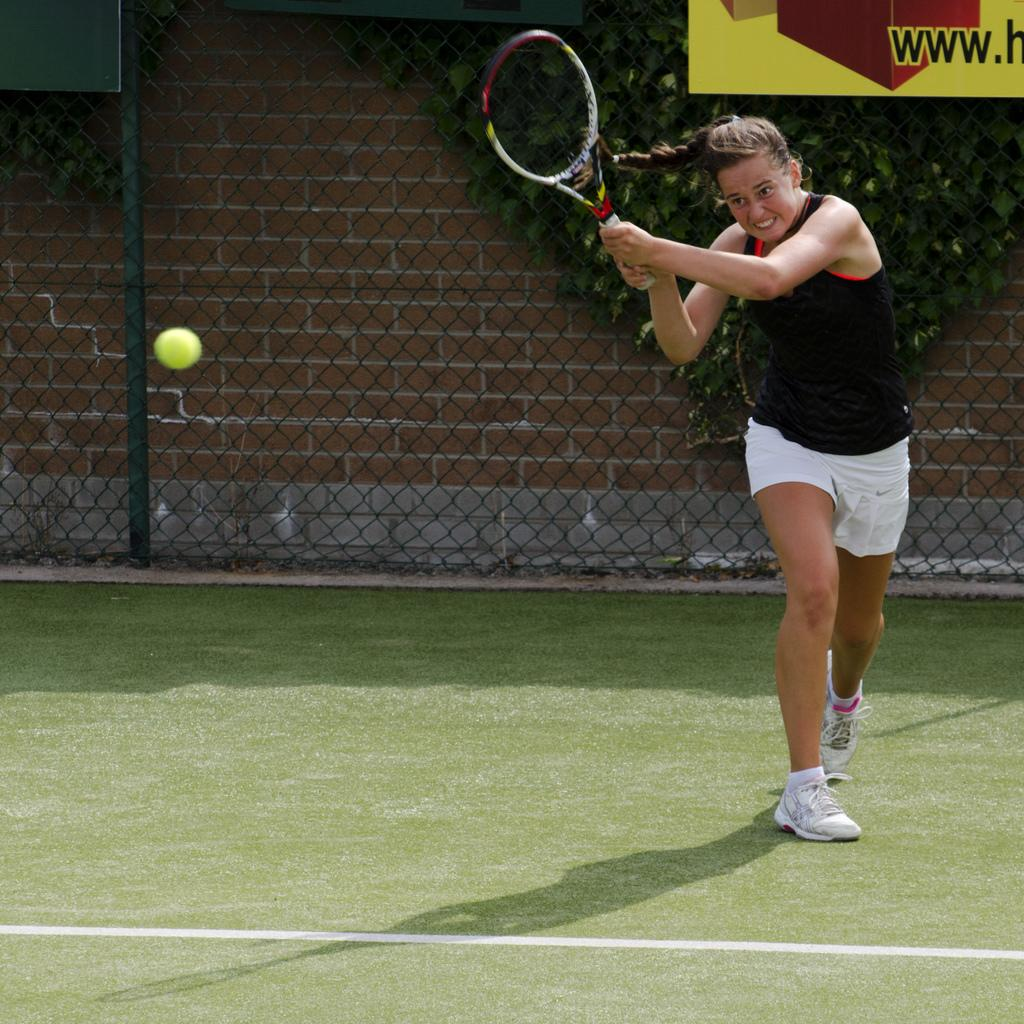What is the main subject of the image? There is a woman in the image. What is the woman doing in the image? The woman is standing and holding a racket. What else can be seen in the image besides the woman? There is a ball, a fence, a banner, a wall, and plants in the background of the image. Where is the desk located in the image? There is no desk present in the image. What type of basket is being used by the woman in the image? There is no basket present in the image; the woman is holding a racket. 